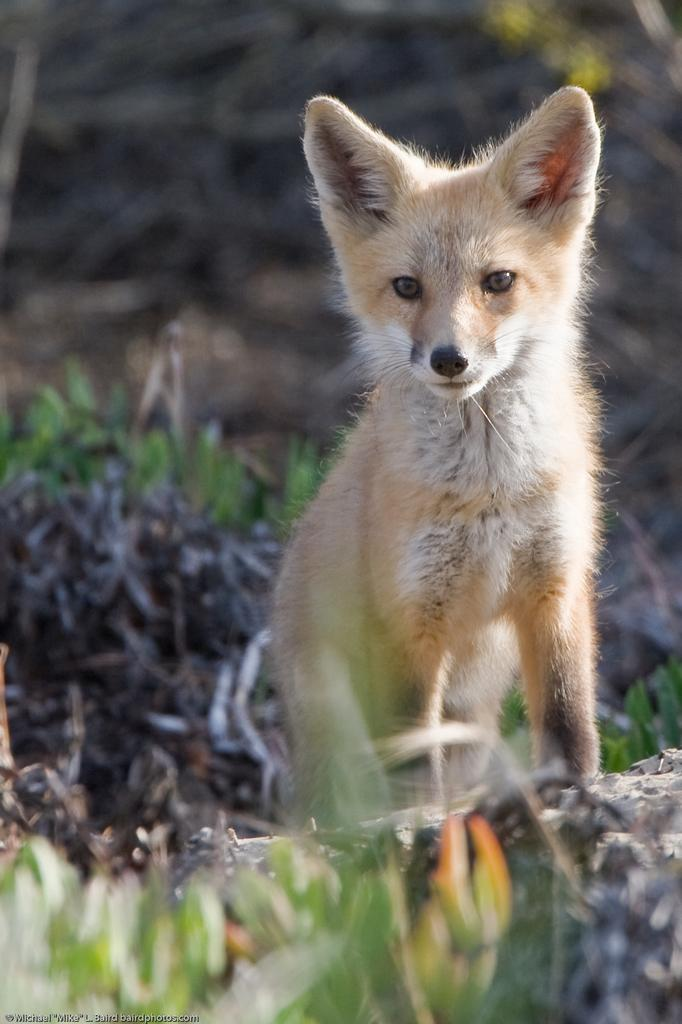What type of animal can be seen in the image? There is an animal in the image, and it looks like a fox. What colors are present on the animal? The animal is in cream and white color. What is visible on the ground in the image? There is grass visible on the ground. How would you describe the background of the image? The background of the image is blurred. What suggestion does the fox make to the roof in the image? There is no roof present in the image, and the fox does not make any suggestions. 